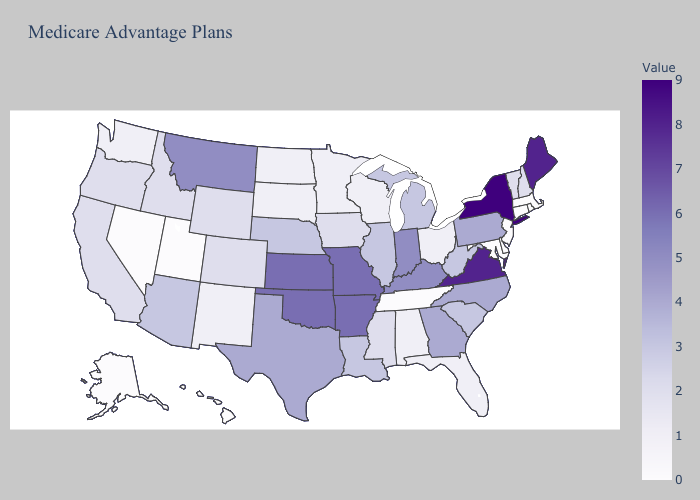Does Maine have the highest value in the Northeast?
Keep it brief. No. Which states have the lowest value in the Northeast?
Quick response, please. Connecticut, Massachusetts, New Jersey, Rhode Island. Is the legend a continuous bar?
Answer briefly. Yes. Which states have the lowest value in the Northeast?
Write a very short answer. Connecticut, Massachusetts, New Jersey, Rhode Island. Does the map have missing data?
Give a very brief answer. No. Which states have the lowest value in the USA?
Quick response, please. Alaska, Connecticut, Delaware, Hawaii, Massachusetts, Maryland, New Jersey, Nevada, Rhode Island, Tennessee, Utah. Does Arizona have the lowest value in the USA?
Give a very brief answer. No. Does South Dakota have the lowest value in the USA?
Answer briefly. No. 